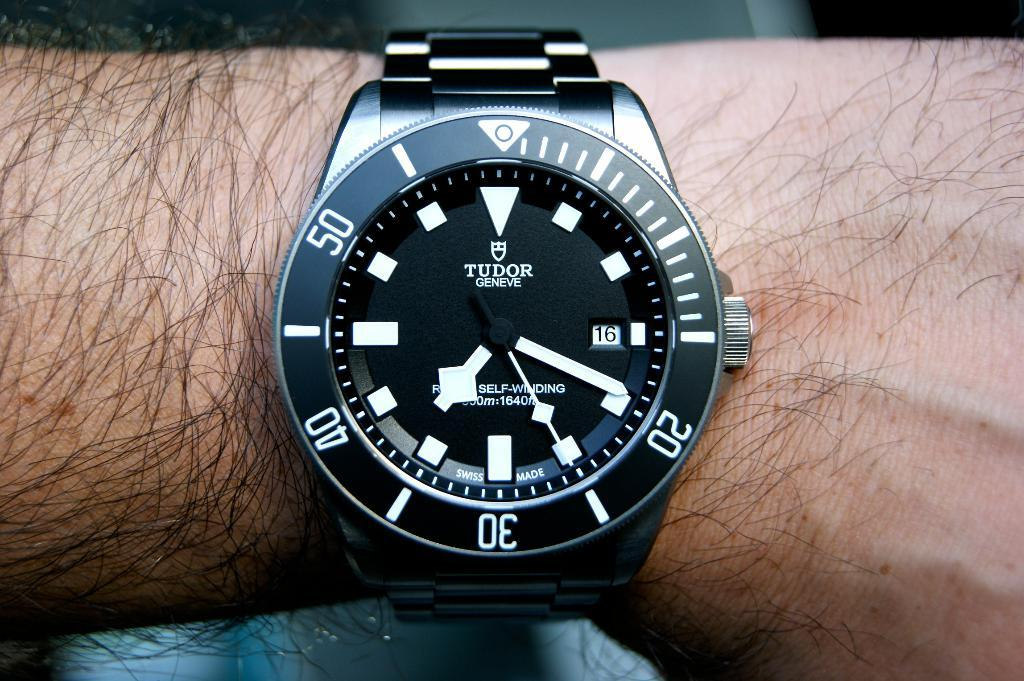<image>
Share a concise interpretation of the image provided. A man wears a Tudor watch with a black face around his wrist. 